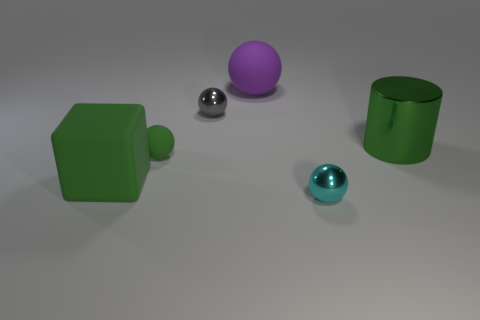Add 2 large cyan cubes. How many objects exist? 8 Subtract all blocks. How many objects are left? 5 Subtract all green rubber objects. Subtract all cylinders. How many objects are left? 3 Add 2 purple matte spheres. How many purple matte spheres are left? 3 Add 5 small objects. How many small objects exist? 8 Subtract 1 green cubes. How many objects are left? 5 